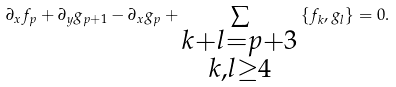Convert formula to latex. <formula><loc_0><loc_0><loc_500><loc_500>\partial _ { x } f _ { p } + \partial _ { y } g _ { p + 1 } - \partial _ { x } g _ { p } + \sum _ { \substack { k + l = p + 3 \\ k , l \geq 4 } } \left \{ f _ { k } , g _ { l } \right \} = 0 .</formula> 